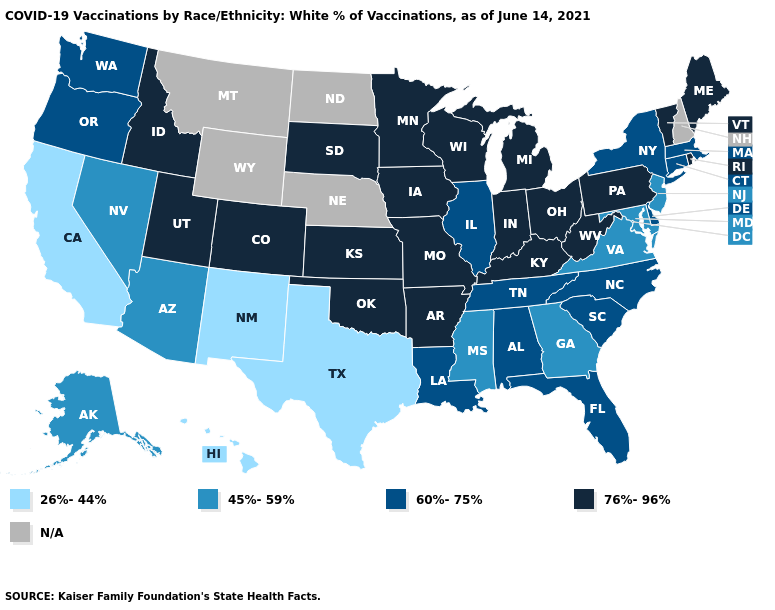What is the lowest value in states that border Delaware?
Short answer required. 45%-59%. Among the states that border Kentucky , does West Virginia have the highest value?
Write a very short answer. Yes. What is the value of Arizona?
Quick response, please. 45%-59%. Name the states that have a value in the range 45%-59%?
Answer briefly. Alaska, Arizona, Georgia, Maryland, Mississippi, Nevada, New Jersey, Virginia. What is the value of Iowa?
Give a very brief answer. 76%-96%. What is the value of Vermont?
Give a very brief answer. 76%-96%. Which states have the lowest value in the MidWest?
Be succinct. Illinois. Among the states that border Delaware , which have the highest value?
Write a very short answer. Pennsylvania. Does the first symbol in the legend represent the smallest category?
Write a very short answer. Yes. What is the lowest value in states that border New York?
Be succinct. 45%-59%. Name the states that have a value in the range 60%-75%?
Quick response, please. Alabama, Connecticut, Delaware, Florida, Illinois, Louisiana, Massachusetts, New York, North Carolina, Oregon, South Carolina, Tennessee, Washington. Does the first symbol in the legend represent the smallest category?
Answer briefly. Yes. Name the states that have a value in the range 76%-96%?
Be succinct. Arkansas, Colorado, Idaho, Indiana, Iowa, Kansas, Kentucky, Maine, Michigan, Minnesota, Missouri, Ohio, Oklahoma, Pennsylvania, Rhode Island, South Dakota, Utah, Vermont, West Virginia, Wisconsin. What is the value of Mississippi?
Quick response, please. 45%-59%. What is the lowest value in the West?
Write a very short answer. 26%-44%. 